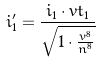Convert formula to latex. <formula><loc_0><loc_0><loc_500><loc_500>i _ { 1 } ^ { \prime } = \frac { i _ { 1 } \cdot v t _ { 1 } } { \sqrt { 1 \cdot \frac { v ^ { 8 } } { n ^ { 8 } } } }</formula> 